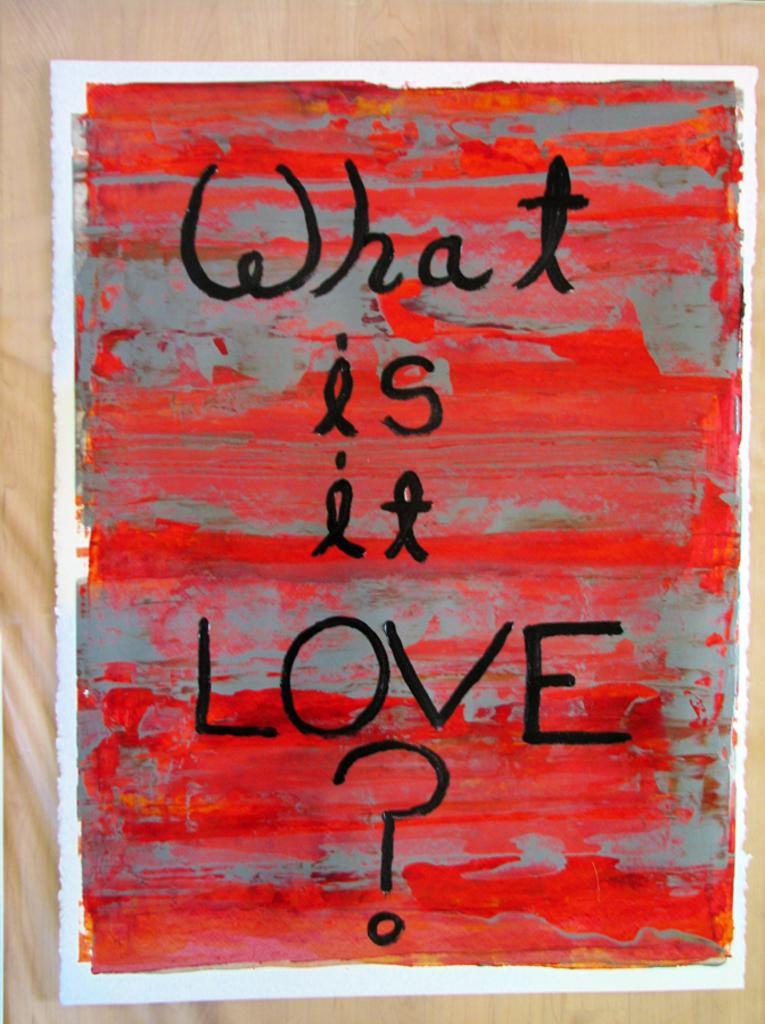<image>
Give a short and clear explanation of the subsequent image. The question being asked is about what love is. 